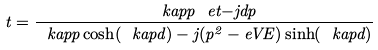<formula> <loc_0><loc_0><loc_500><loc_500>t = \frac { \ k a p p \ e t { - j d p } } { \ k a p p \cosh ( \ k a p d ) - j ( p ^ { 2 } - e V E ) \sinh ( \ k a p d ) }</formula> 